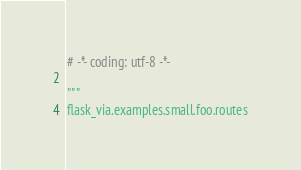<code> <loc_0><loc_0><loc_500><loc_500><_Python_># -*- coding: utf-8 -*-

"""
flask_via.examples.small.foo.routes</code> 